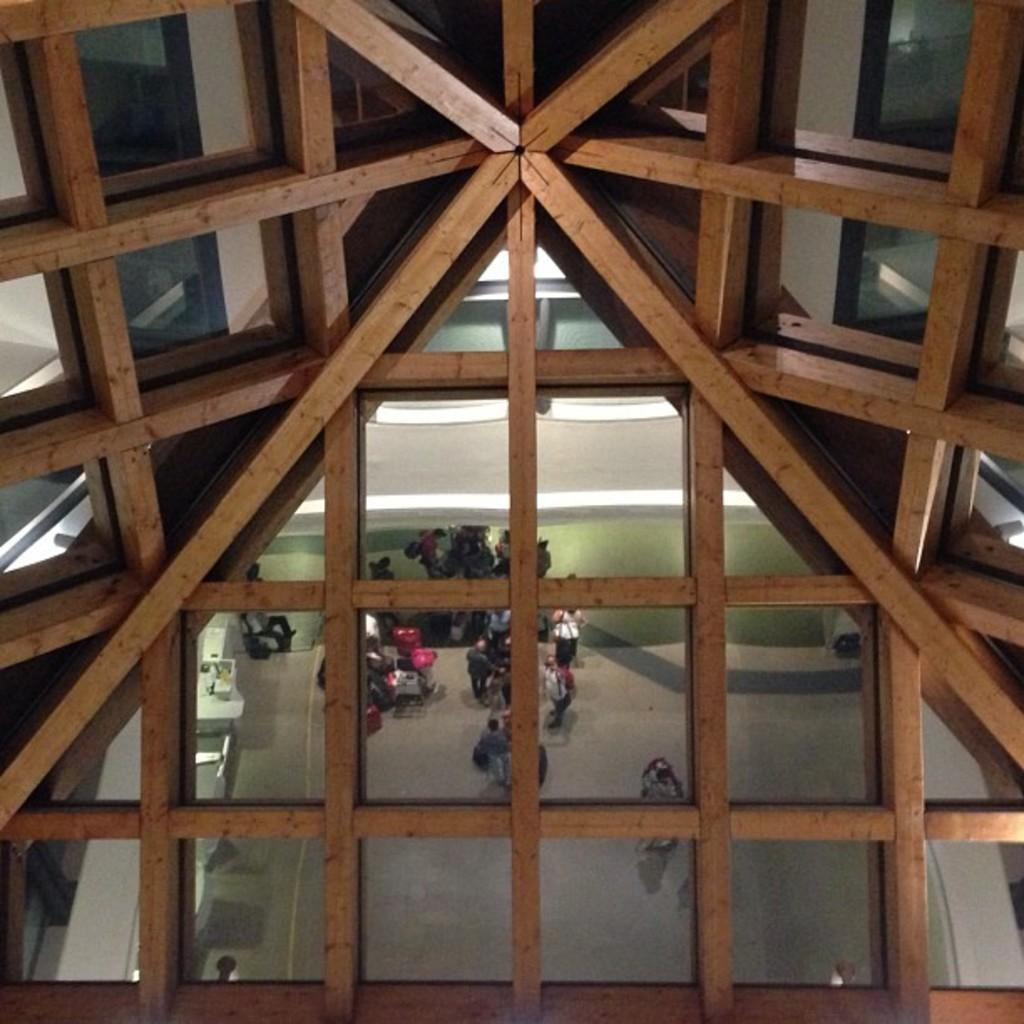What part of a building is shown in the image? The image shows the ceiling of a building. What can be seen on the ceiling due to the reflection? There is a reflection of people on the ceiling. What other elements can be seen in the reflection? The wall, the floor, and other objects are visible in the reflection. How many eyes can be seen on the bee in the image? There is no bee present in the image; it shows the ceiling of a building with a reflection of people and other elements. 